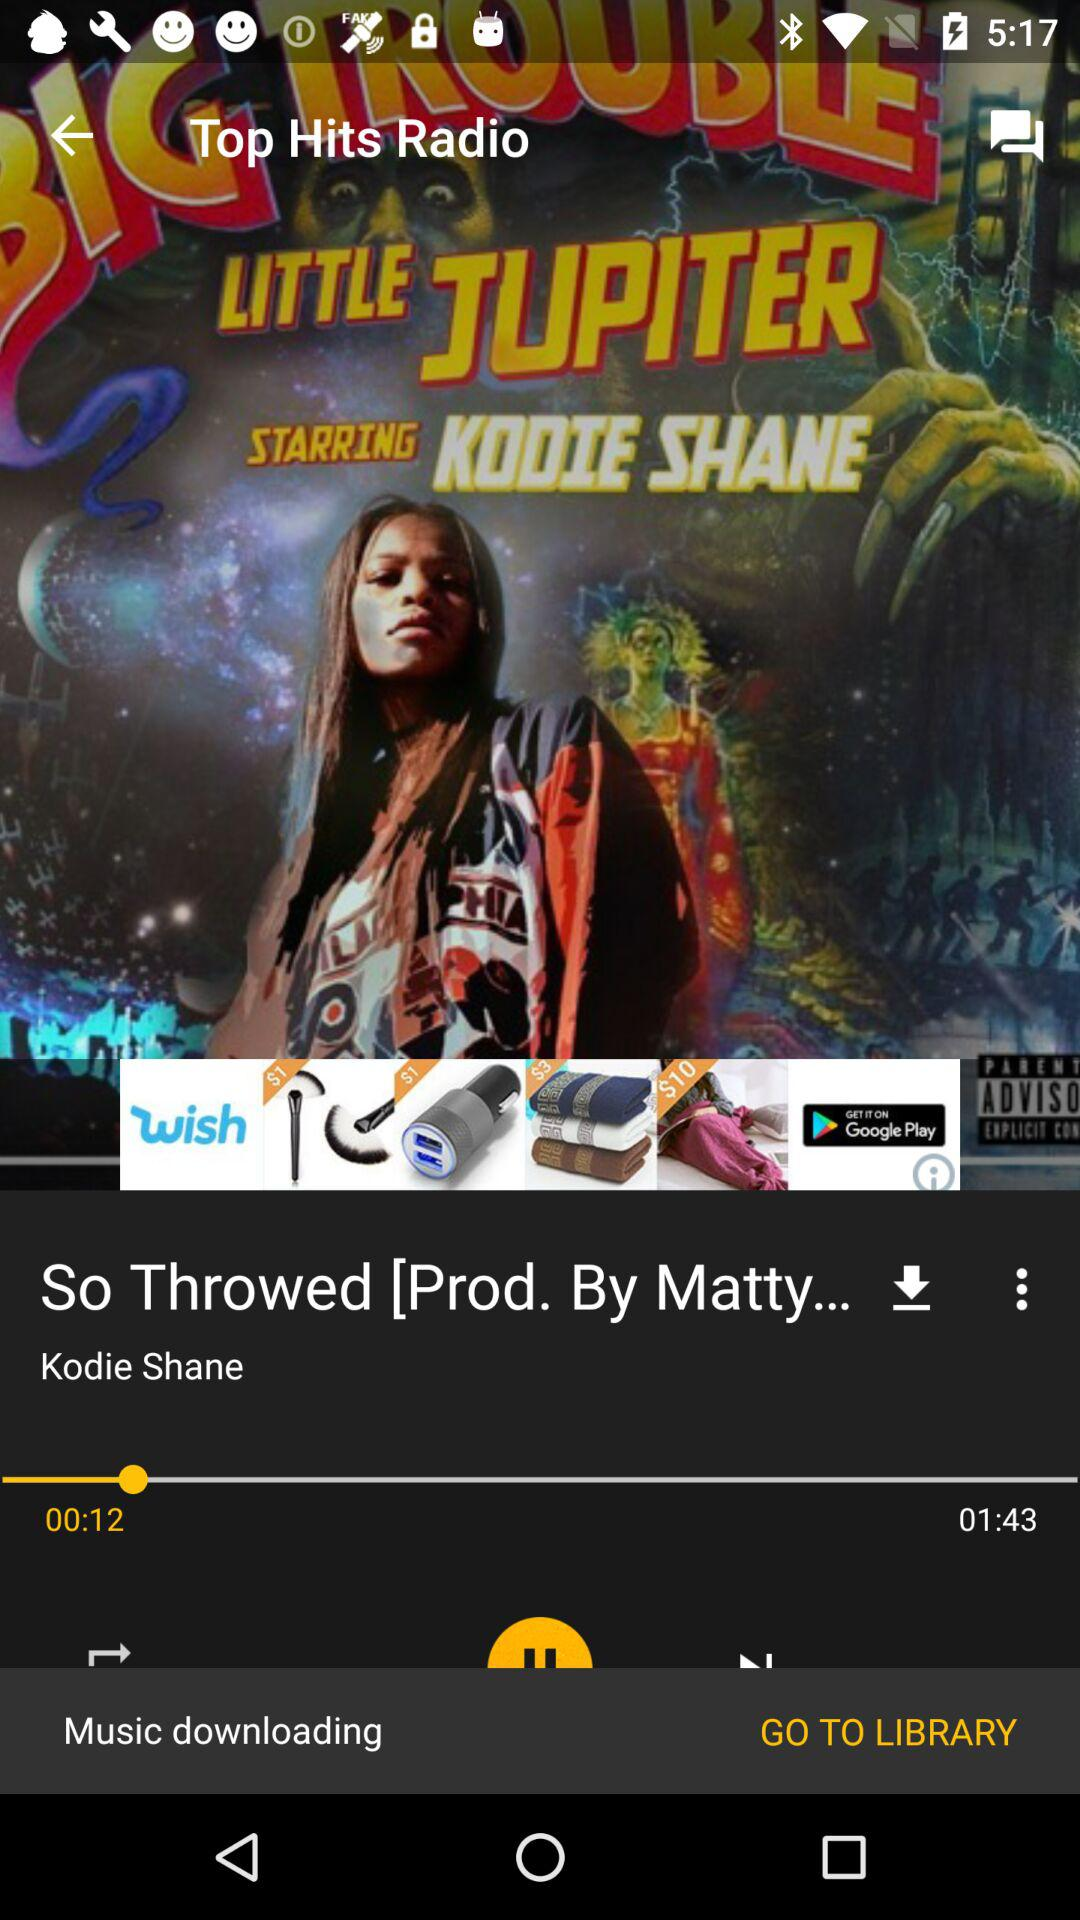What is the singer's name? The singer's name is Kodie Shane. 